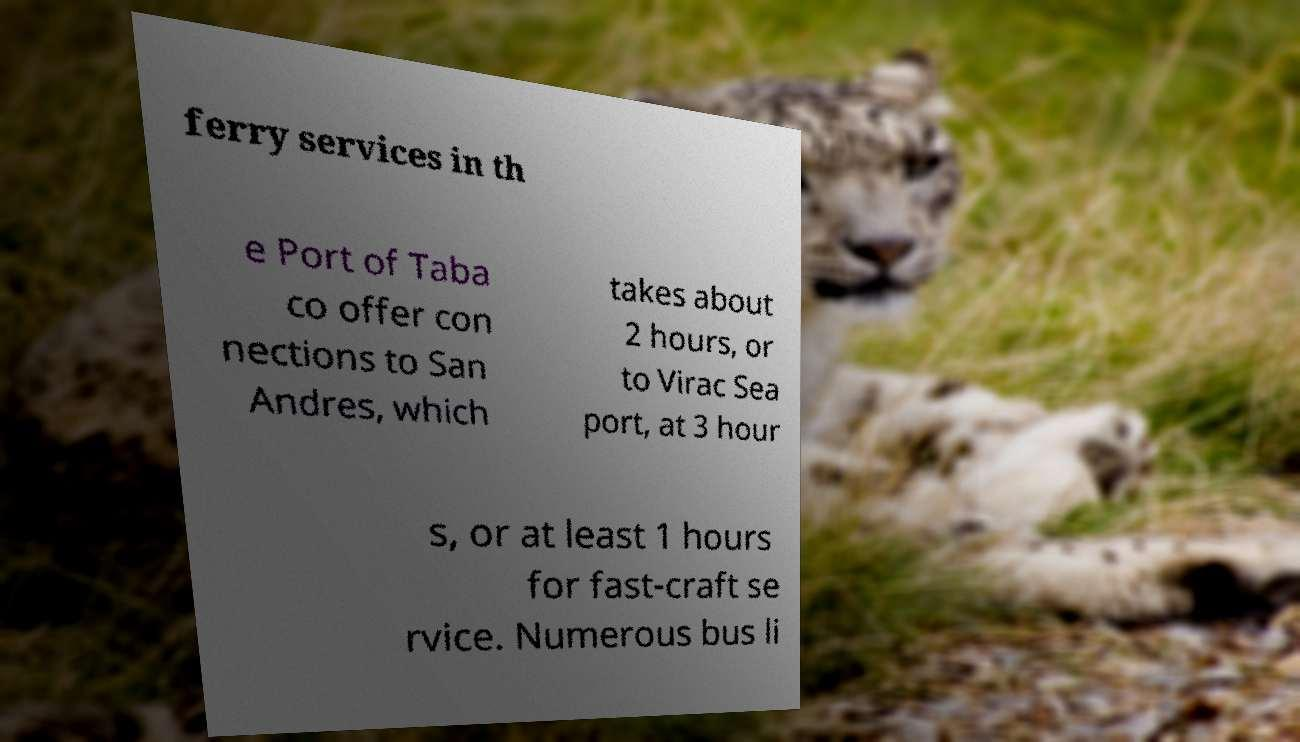Please identify and transcribe the text found in this image. ferry services in th e Port of Taba co offer con nections to San Andres, which takes about 2 hours, or to Virac Sea port, at 3 hour s, or at least 1 hours for fast-craft se rvice. Numerous bus li 